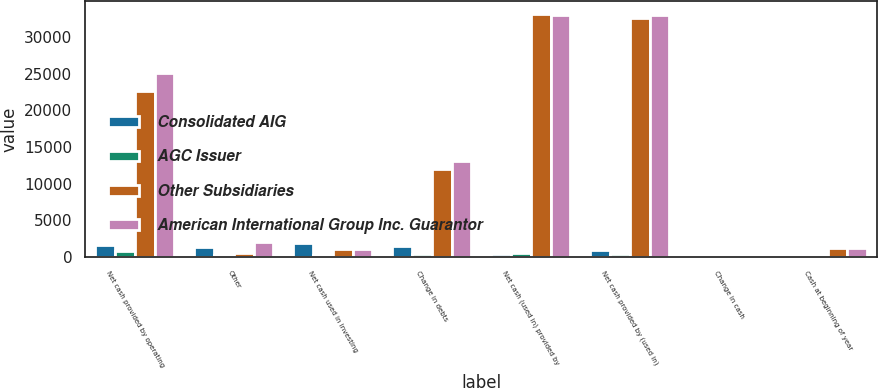Convert chart to OTSL. <chart><loc_0><loc_0><loc_500><loc_500><stacked_bar_chart><ecel><fcel>Net cash provided by operating<fcel>Other<fcel>Net cash used in investing<fcel>Change in debts<fcel>Net cash (used in) provided by<fcel>Net cash provided by (used in)<fcel>Change in cash<fcel>Cash at beginning of year<nl><fcel>Consolidated AIG<fcel>1673<fcel>1294<fcel>1892<fcel>1493<fcel>317<fcel>877<fcel>1<fcel>18<nl><fcel>AGC Issuer<fcel>805<fcel>247<fcel>247<fcel>398<fcel>558<fcel>451<fcel>1<fcel>1<nl><fcel>Other Subsidiaries<fcel>22660<fcel>477<fcel>1011.5<fcel>11939<fcel>33240<fcel>32644<fcel>243<fcel>1146<nl><fcel>American International Group Inc. Guarantor<fcel>25138<fcel>2018<fcel>1011.5<fcel>13034<fcel>32999<fcel>33070<fcel>243<fcel>1165<nl></chart> 